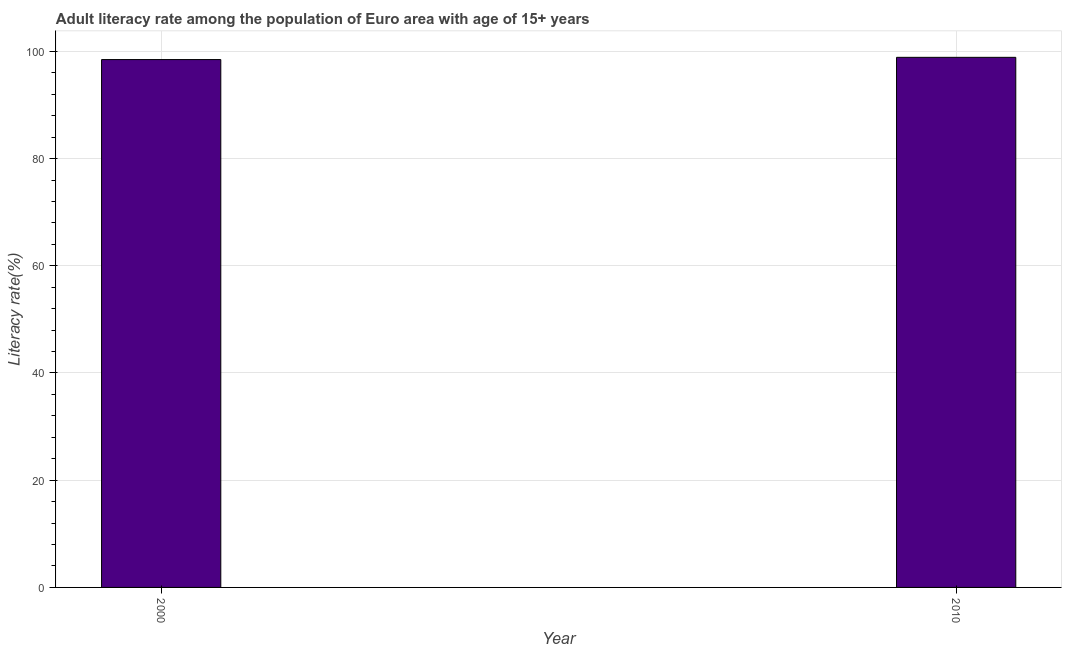What is the title of the graph?
Provide a succinct answer. Adult literacy rate among the population of Euro area with age of 15+ years. What is the label or title of the Y-axis?
Your answer should be very brief. Literacy rate(%). What is the adult literacy rate in 2010?
Make the answer very short. 98.88. Across all years, what is the maximum adult literacy rate?
Provide a succinct answer. 98.88. Across all years, what is the minimum adult literacy rate?
Provide a succinct answer. 98.47. In which year was the adult literacy rate minimum?
Offer a terse response. 2000. What is the sum of the adult literacy rate?
Offer a terse response. 197.35. What is the difference between the adult literacy rate in 2000 and 2010?
Provide a short and direct response. -0.42. What is the average adult literacy rate per year?
Provide a succinct answer. 98.67. What is the median adult literacy rate?
Provide a short and direct response. 98.68. Is the adult literacy rate in 2000 less than that in 2010?
Keep it short and to the point. Yes. How many bars are there?
Keep it short and to the point. 2. What is the difference between two consecutive major ticks on the Y-axis?
Provide a succinct answer. 20. What is the Literacy rate(%) of 2000?
Offer a very short reply. 98.47. What is the Literacy rate(%) in 2010?
Keep it short and to the point. 98.88. What is the difference between the Literacy rate(%) in 2000 and 2010?
Provide a succinct answer. -0.42. What is the ratio of the Literacy rate(%) in 2000 to that in 2010?
Offer a terse response. 1. 